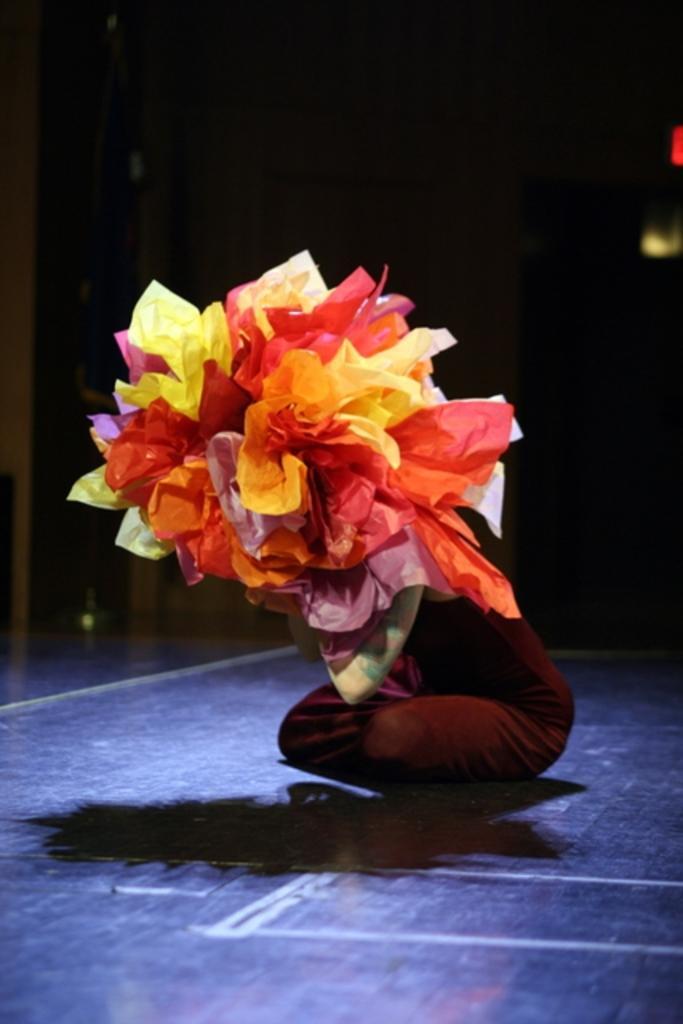How would you summarize this image in a sentence or two? This image is taken indoors. In this image the background is dark. In the middle of the image a person is in a squatting position and holding a bunch of colored papers in the hands. 